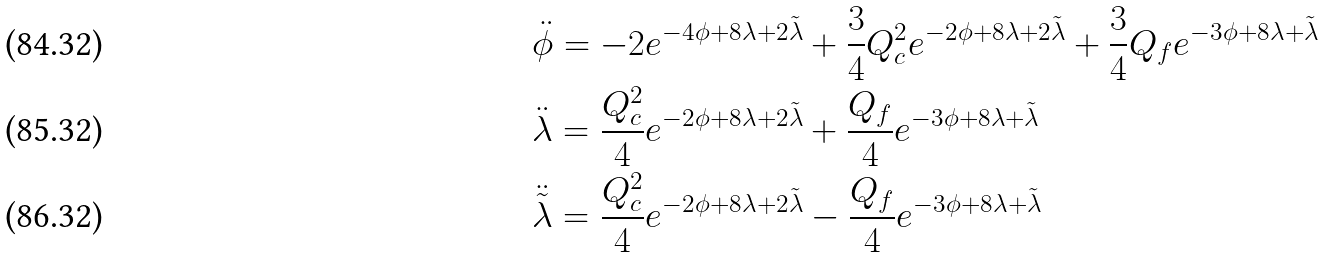<formula> <loc_0><loc_0><loc_500><loc_500>& \ddot { \phi } = - 2 e ^ { - 4 \phi + 8 \lambda + 2 \tilde { \lambda } } + \frac { 3 } { 4 } Q _ { c } ^ { 2 } e ^ { - 2 \phi + 8 \lambda + 2 \tilde { \lambda } } + \frac { 3 } { 4 } Q _ { f } e ^ { - 3 \phi + 8 \lambda + \tilde { \lambda } } \\ & \ddot { \lambda } = \frac { Q _ { c } ^ { 2 } } { 4 } e ^ { - 2 \phi + 8 \lambda + 2 \tilde { \lambda } } + \frac { Q _ { f } } { 4 } e ^ { - 3 \phi + 8 \lambda + \tilde { \lambda } } \\ & \ddot { \tilde { \lambda } } = \frac { Q _ { c } ^ { 2 } } { 4 } e ^ { - 2 \phi + 8 \lambda + 2 \tilde { \lambda } } - \frac { Q _ { f } } { 4 } e ^ { - 3 \phi + 8 \lambda + \tilde { \lambda } }</formula> 